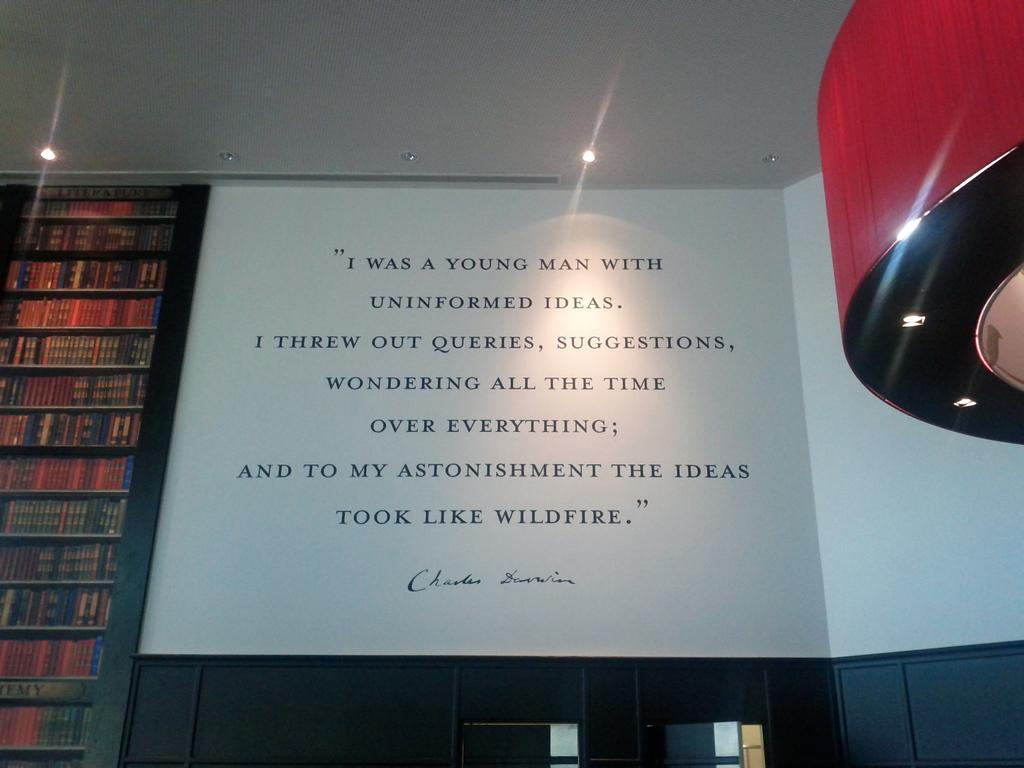<image>
Create a compact narrative representing the image presented. a BOOK IS OPEN TO A PAGE THAT STARTS WITH i WAS A YOUNG MAN. 